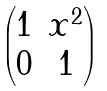Convert formula to latex. <formula><loc_0><loc_0><loc_500><loc_500>\begin{pmatrix} 1 & x ^ { 2 } \\ 0 & 1 \end{pmatrix}</formula> 